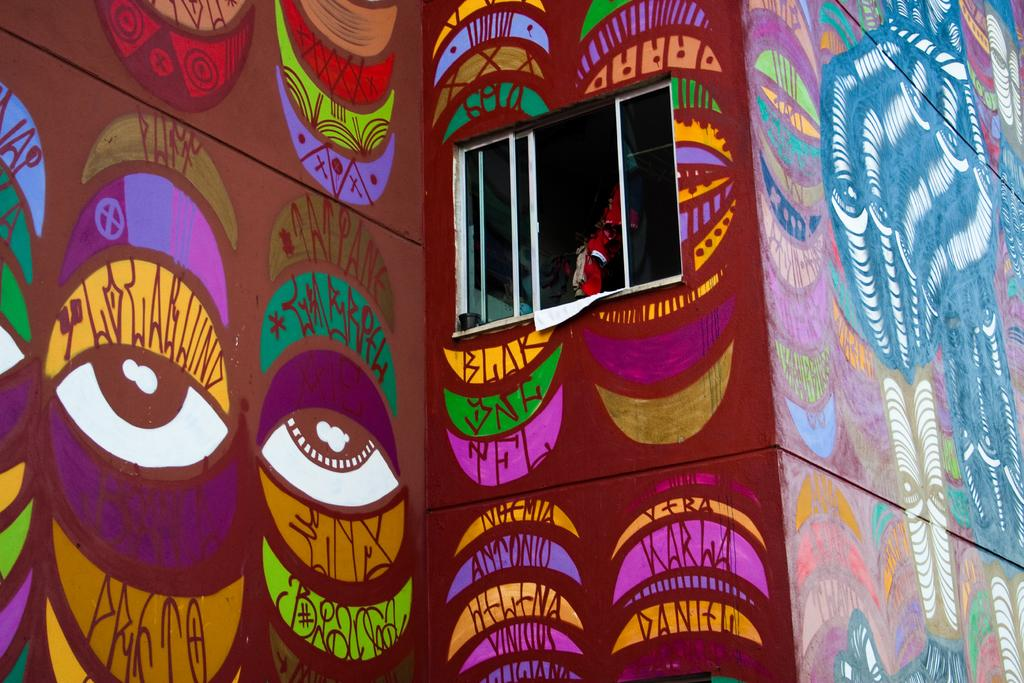What is displayed on the wall in the image? There is an art piece on the wall in the image. What architectural feature is present in the middle of the image? There is a window in the middle of the image. What type of creature can be seen interacting with the art piece in the image? There is no creature present in the image; it only features an art piece on the wall and a window. How does the group of people increase the value of the art piece in the image? There is no group of people present in the image, so their influence on the art piece cannot be determined. 